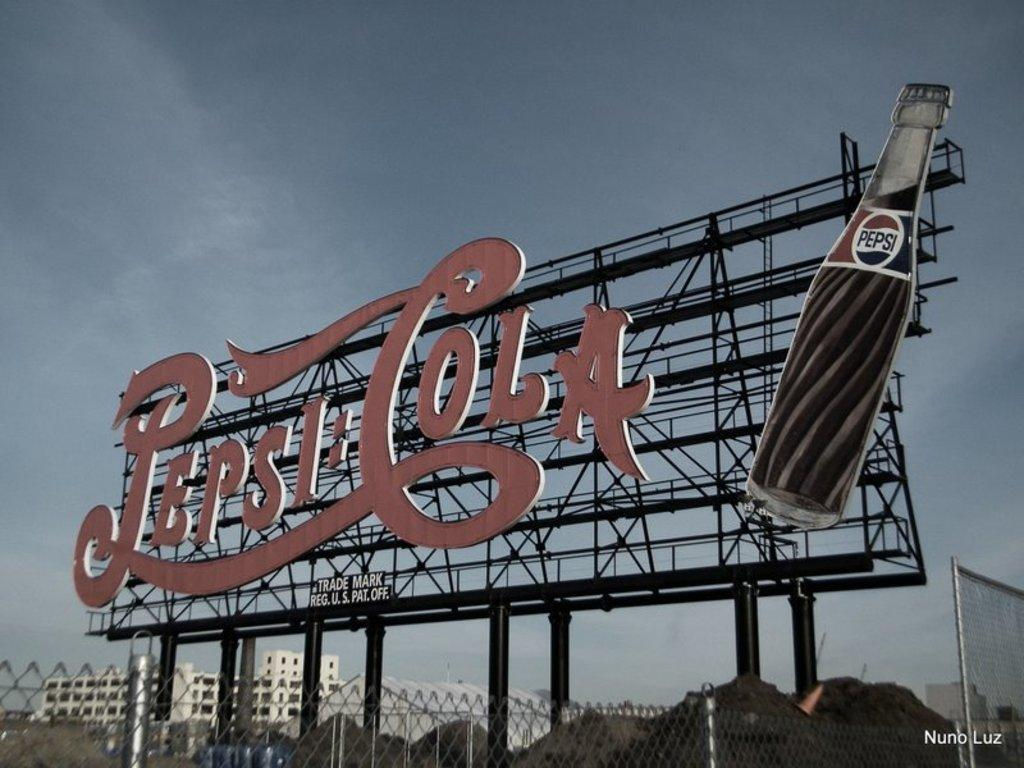<image>
Offer a succinct explanation of the picture presented. A large Pepsi Cola sign features an image of a glass soda bottle. 